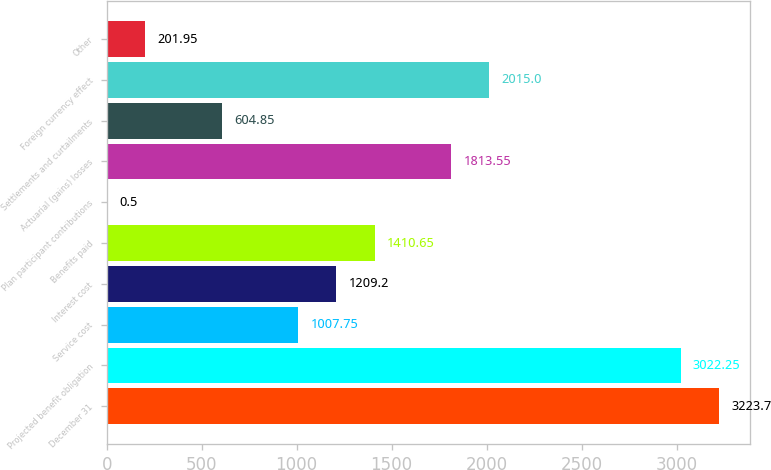<chart> <loc_0><loc_0><loc_500><loc_500><bar_chart><fcel>December 31<fcel>Projected benefit obligation<fcel>Service cost<fcel>Interest cost<fcel>Benefits paid<fcel>Plan participant contributions<fcel>Actuarial (gains) losses<fcel>Settlements and curtailments<fcel>Foreign currency effect<fcel>Other<nl><fcel>3223.7<fcel>3022.25<fcel>1007.75<fcel>1209.2<fcel>1410.65<fcel>0.5<fcel>1813.55<fcel>604.85<fcel>2015<fcel>201.95<nl></chart> 